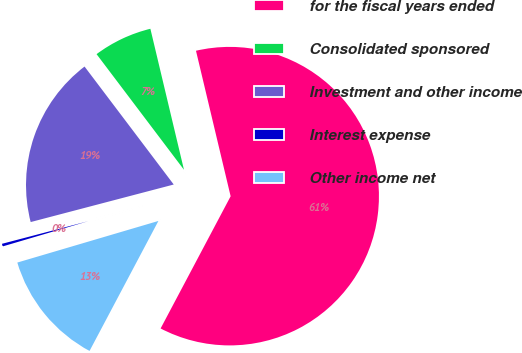<chart> <loc_0><loc_0><loc_500><loc_500><pie_chart><fcel>for the fiscal years ended<fcel>Consolidated sponsored<fcel>Investment and other income<fcel>Interest expense<fcel>Other income net<nl><fcel>61.47%<fcel>6.58%<fcel>18.78%<fcel>0.48%<fcel>12.68%<nl></chart> 